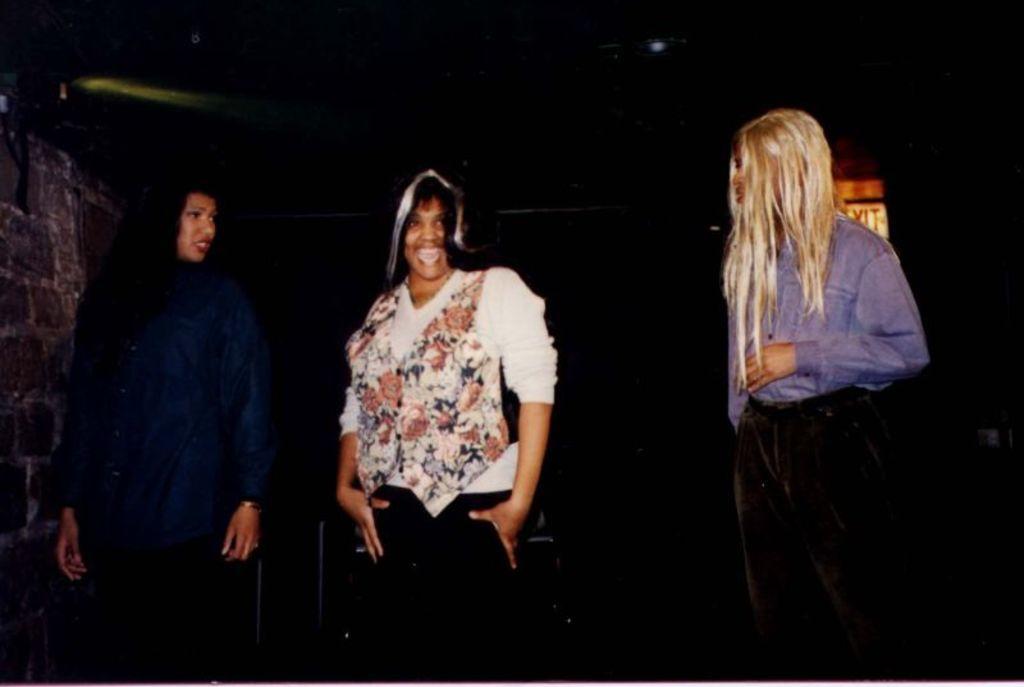Can you describe this image briefly? In this image we can see three women standing. one woman is wearing a blue shirt and one woman is wearing a white shirt. 